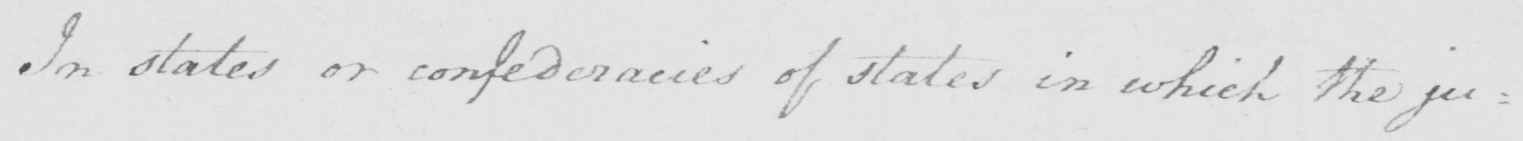Please provide the text content of this handwritten line. In states or confederacies of states in which the ju : 